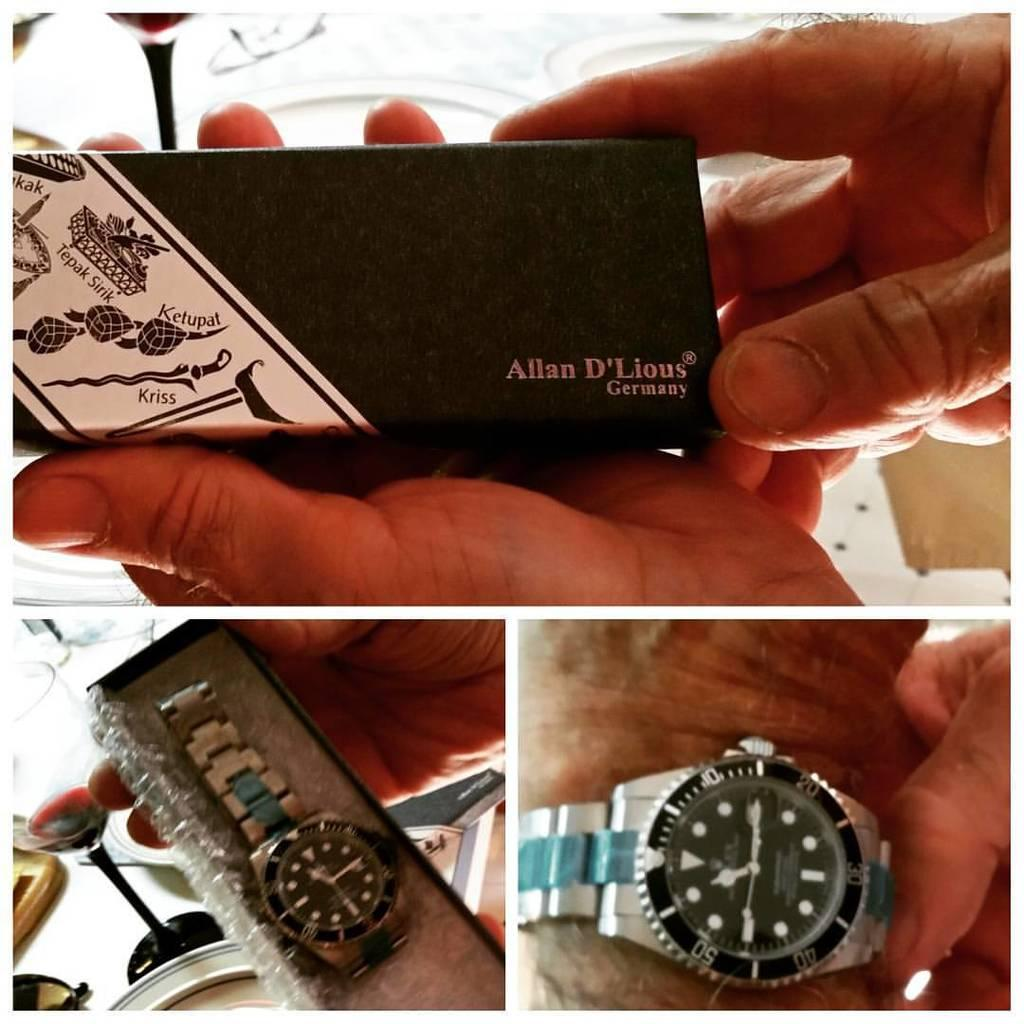<image>
Create a compact narrative representing the image presented. A beautiful watch in a decorative box from Allan D'Lious Germany. 